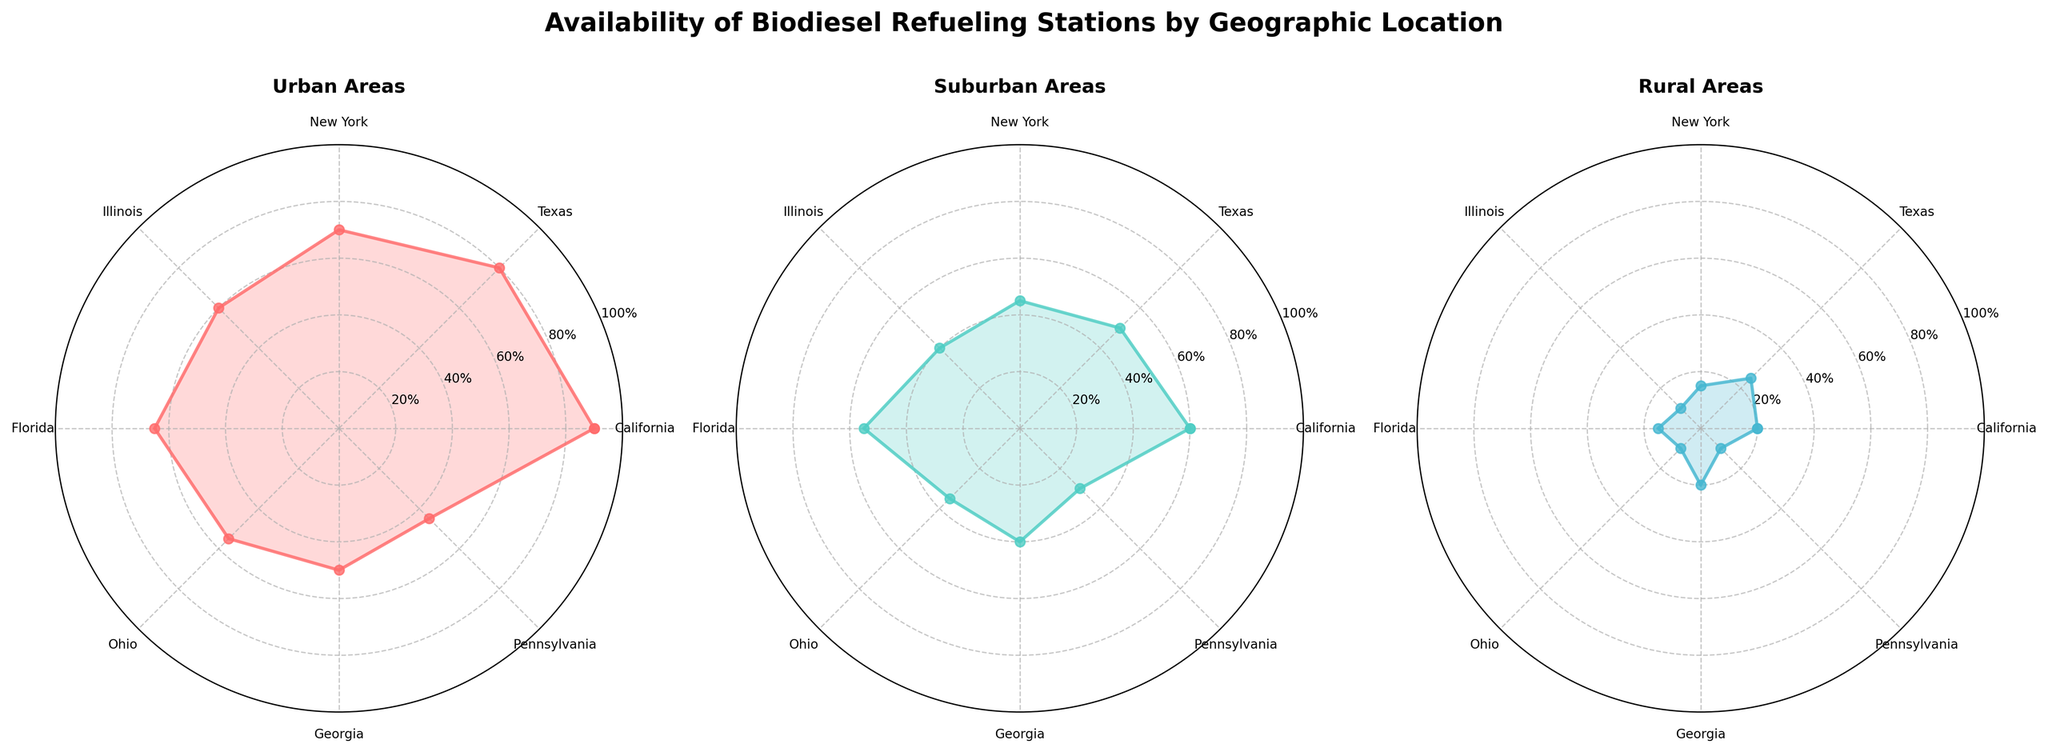Which region has the highest availability of biodiesel refueling stations in urban areas? The radar chart for urban areas shows that California has the highest data point at the outermost point compared to other regions.
Answer: California Which region has a greater availability of biodiesel refueling stations in suburban areas: Texas or Ohio? In the suburban areas radar chart, Texas has a data point positioned higher (closer to the outer circle) than Ohio.
Answer: Texas What is the minimum availability percentage of biodiesel refueling stations in rural areas among all regions? By examining the rural areas radar chart, Pennsylvania and Illinois have the lowest data points on the innermost circle, with both showing 10%.
Answer: 10% What is the average availability of biodiesel refueling stations in suburban areas for New York and Florida? The suburban areas radar chart shows New York at 45% and Florida at 55%. The average is calculated as (45 + 55) / 2 = 50%.
Answer: 50% How does the availability of biodiesel refueling stations in rural areas for Texas compare to Illinois? The radar chart for rural areas shows that Texas has a data point at 25% while Illinois at 10%, indicating Texas has more availability.
Answer: Texas has more How many geographic regions have more than 50% availability of biodiesel refueling stations in suburban areas? By observing the suburban areas radar chart, California, Florida, and Texas have data points above 50%. This counts to 3 regions.
Answer: 3 Which geographic region has the second highest availability of biodiesel refueling stations in urban areas? In the urban areas radar chart, Texas, with 80%, is the second outermost point after California.
Answer: Texas What is the difference in availability of biodiesel refueling stations between urban and rural areas for California? California shows 90% in urban areas and 20% in rural areas. The difference is 90 - 20 = 70%.
Answer: 70% 